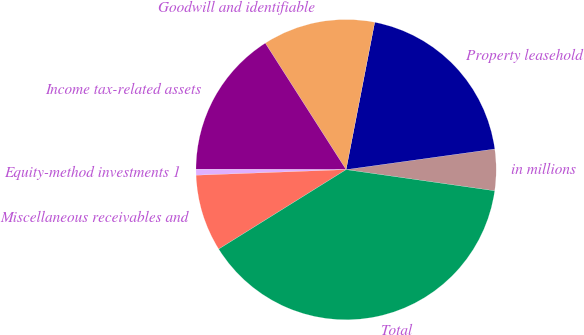Convert chart to OTSL. <chart><loc_0><loc_0><loc_500><loc_500><pie_chart><fcel>in millions<fcel>Property leasehold<fcel>Goodwill and identifiable<fcel>Income tax-related assets<fcel>Equity-method investments 1<fcel>Miscellaneous receivables and<fcel>Total<nl><fcel>4.45%<fcel>19.75%<fcel>12.1%<fcel>15.92%<fcel>0.63%<fcel>8.28%<fcel>38.87%<nl></chart> 